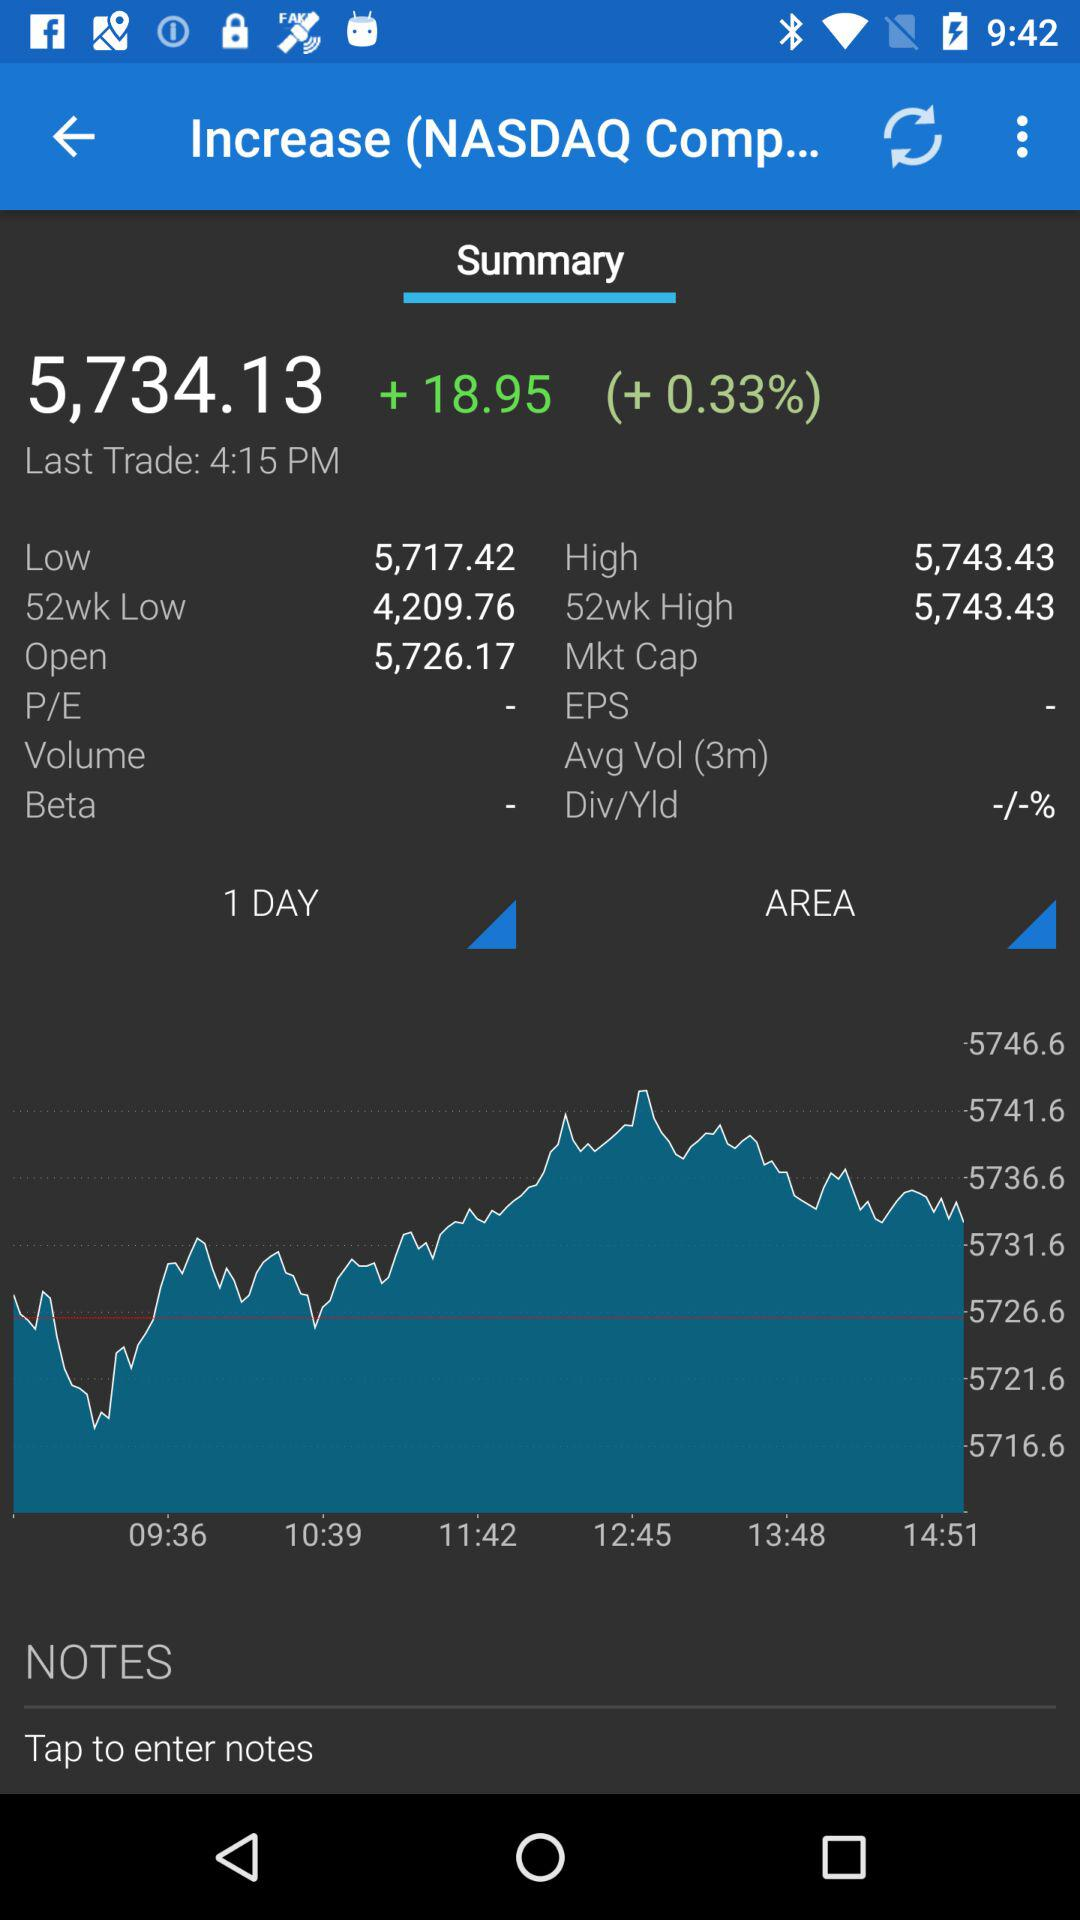What is the profit percentage? The profit percentage is 0.33. 